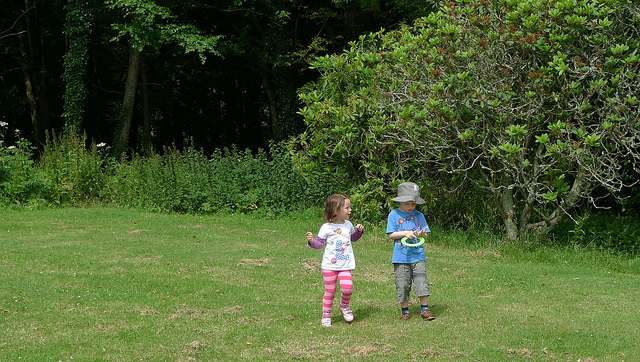<image>Why the head protection? I'm not sure why the head protection is needed. It could be for protection from the sun. What type of fruit grows on the trees in the background? It is unknown what type of fruit grows on the trees in the background. The types could be oranges, apples, or cherries. Why the head protection? I don't know why the head protection is needed. It can be for protection from the sun or to provide shade on a sunny day. What type of fruit grows on the trees in the background? It is unclear what type of fruit grows on the trees in the background. It can be oranges, apples or cherry. 